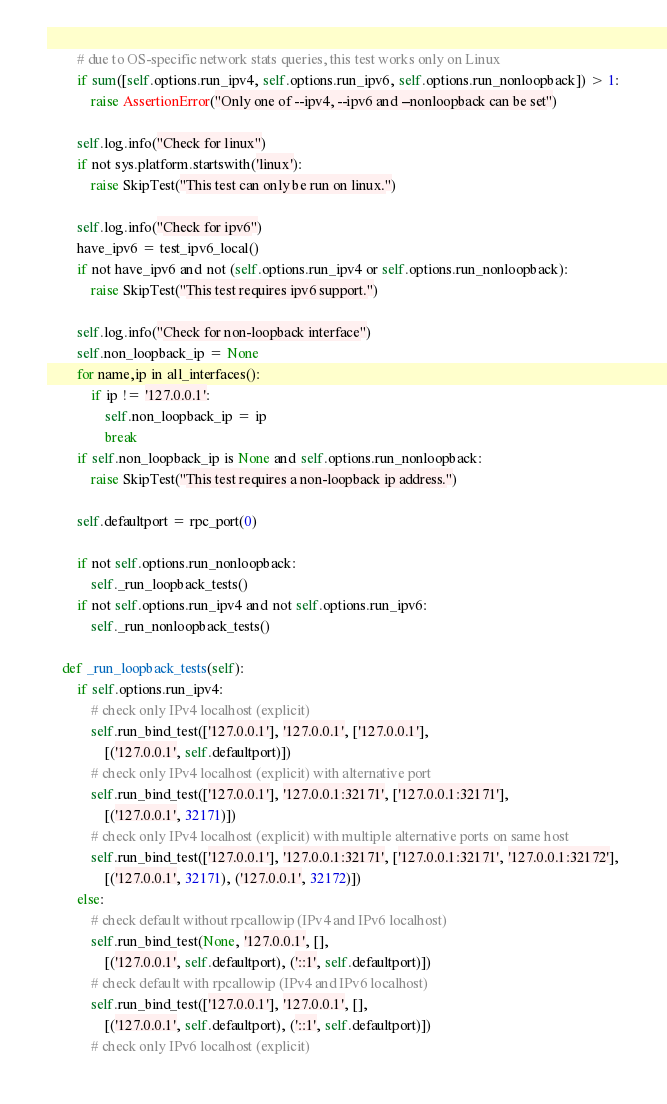Convert code to text. <code><loc_0><loc_0><loc_500><loc_500><_Python_>        # due to OS-specific network stats queries, this test works only on Linux
        if sum([self.options.run_ipv4, self.options.run_ipv6, self.options.run_nonloopback]) > 1:
            raise AssertionError("Only one of --ipv4, --ipv6 and --nonloopback can be set")

        self.log.info("Check for linux")
        if not sys.platform.startswith('linux'):
            raise SkipTest("This test can only be run on linux.")

        self.log.info("Check for ipv6")
        have_ipv6 = test_ipv6_local()
        if not have_ipv6 and not (self.options.run_ipv4 or self.options.run_nonloopback):
            raise SkipTest("This test requires ipv6 support.")

        self.log.info("Check for non-loopback interface")
        self.non_loopback_ip = None
        for name,ip in all_interfaces():
            if ip != '127.0.0.1':
                self.non_loopback_ip = ip
                break
        if self.non_loopback_ip is None and self.options.run_nonloopback:
            raise SkipTest("This test requires a non-loopback ip address.")

        self.defaultport = rpc_port(0)

        if not self.options.run_nonloopback:
            self._run_loopback_tests()
        if not self.options.run_ipv4 and not self.options.run_ipv6:
            self._run_nonloopback_tests()

    def _run_loopback_tests(self):
        if self.options.run_ipv4:
            # check only IPv4 localhost (explicit)
            self.run_bind_test(['127.0.0.1'], '127.0.0.1', ['127.0.0.1'],
                [('127.0.0.1', self.defaultport)])
            # check only IPv4 localhost (explicit) with alternative port
            self.run_bind_test(['127.0.0.1'], '127.0.0.1:32171', ['127.0.0.1:32171'],
                [('127.0.0.1', 32171)])
            # check only IPv4 localhost (explicit) with multiple alternative ports on same host
            self.run_bind_test(['127.0.0.1'], '127.0.0.1:32171', ['127.0.0.1:32171', '127.0.0.1:32172'],
                [('127.0.0.1', 32171), ('127.0.0.1', 32172)])
        else:
            # check default without rpcallowip (IPv4 and IPv6 localhost)
            self.run_bind_test(None, '127.0.0.1', [],
                [('127.0.0.1', self.defaultport), ('::1', self.defaultport)])
            # check default with rpcallowip (IPv4 and IPv6 localhost)
            self.run_bind_test(['127.0.0.1'], '127.0.0.1', [],
                [('127.0.0.1', self.defaultport), ('::1', self.defaultport)])
            # check only IPv6 localhost (explicit)</code> 